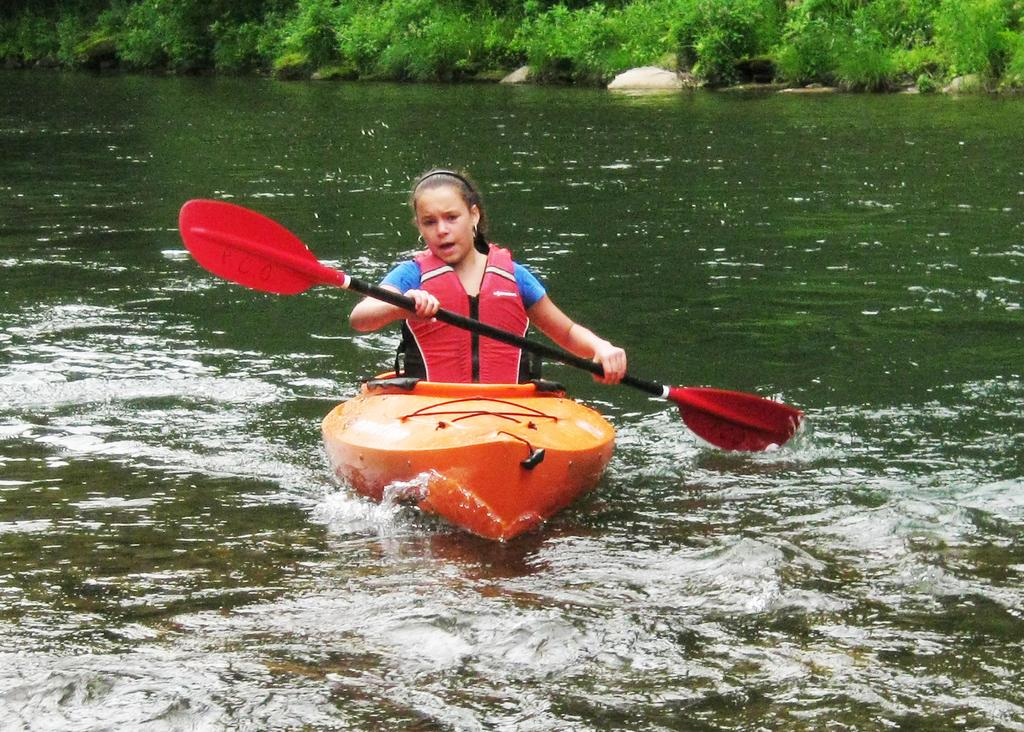Who is the main subject in the image? There is a girl in the image. the image. What is the girl doing in the image? The girl is rowing a boat. What is the environment like in the image? There is water visible in the image. What is the girl using to row the boat? The girl is holding a paddle. What can be seen in the background of the image? There are plants in the background of the image. What type of gold jewelry is the girl wearing in the image? There is no gold jewelry visible on the girl in the image. What type of picture is the girl holding in the image? There is no picture present in the image; the girl is holding a paddle for rowing. 